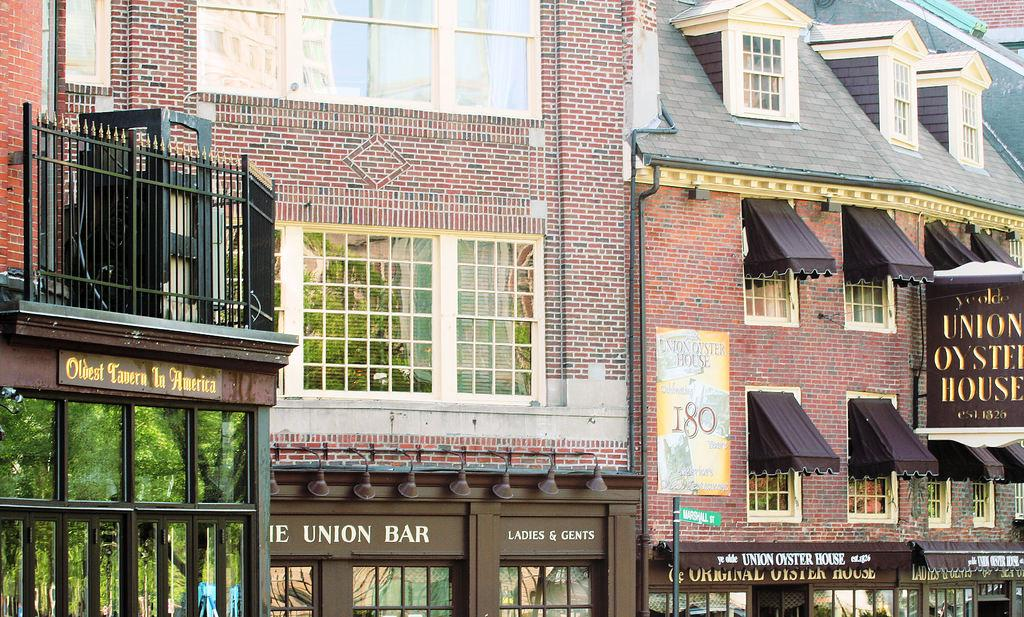What is the color of the house in the image? The house in the image is brown. What color are the windows of the house? The windows of the house are white. What type of establishments can be seen at the bottom of the image? There are shops on the bottom side of the image. Where is the black railing balcony located in the image? The black railing balcony is on the left side of the image. What type of force is being applied to the flag in the image? There is no flag present in the image, so no force is being applied to it. 